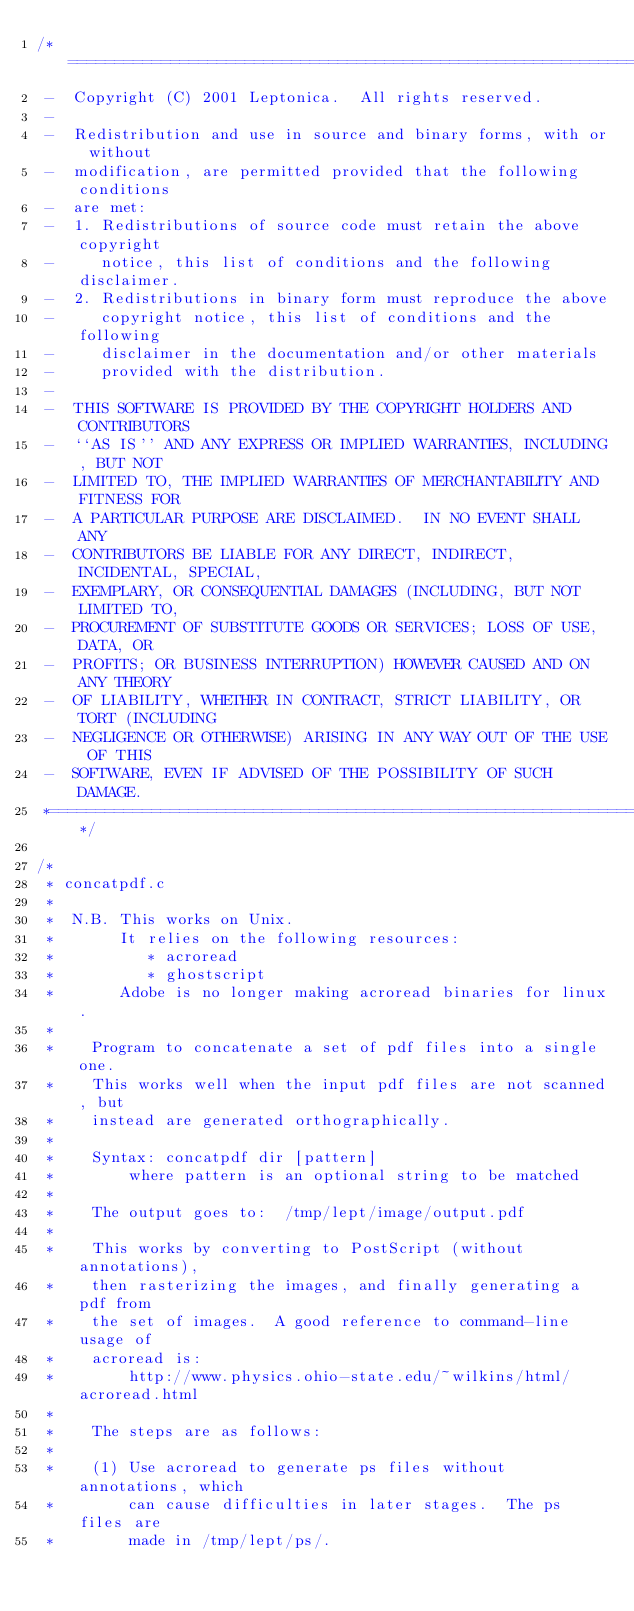Convert code to text. <code><loc_0><loc_0><loc_500><loc_500><_C_>/*====================================================================*
 -  Copyright (C) 2001 Leptonica.  All rights reserved.
 -
 -  Redistribution and use in source and binary forms, with or without
 -  modification, are permitted provided that the following conditions
 -  are met:
 -  1. Redistributions of source code must retain the above copyright
 -     notice, this list of conditions and the following disclaimer.
 -  2. Redistributions in binary form must reproduce the above
 -     copyright notice, this list of conditions and the following
 -     disclaimer in the documentation and/or other materials
 -     provided with the distribution.
 -
 -  THIS SOFTWARE IS PROVIDED BY THE COPYRIGHT HOLDERS AND CONTRIBUTORS
 -  ``AS IS'' AND ANY EXPRESS OR IMPLIED WARRANTIES, INCLUDING, BUT NOT
 -  LIMITED TO, THE IMPLIED WARRANTIES OF MERCHANTABILITY AND FITNESS FOR
 -  A PARTICULAR PURPOSE ARE DISCLAIMED.  IN NO EVENT SHALL ANY
 -  CONTRIBUTORS BE LIABLE FOR ANY DIRECT, INDIRECT, INCIDENTAL, SPECIAL,
 -  EXEMPLARY, OR CONSEQUENTIAL DAMAGES (INCLUDING, BUT NOT LIMITED TO,
 -  PROCUREMENT OF SUBSTITUTE GOODS OR SERVICES; LOSS OF USE, DATA, OR
 -  PROFITS; OR BUSINESS INTERRUPTION) HOWEVER CAUSED AND ON ANY THEORY
 -  OF LIABILITY, WHETHER IN CONTRACT, STRICT LIABILITY, OR TORT (INCLUDING
 -  NEGLIGENCE OR OTHERWISE) ARISING IN ANY WAY OUT OF THE USE OF THIS
 -  SOFTWARE, EVEN IF ADVISED OF THE POSSIBILITY OF SUCH DAMAGE.
 *====================================================================*/

/*
 * concatpdf.c
 *
 *  N.B. This works on Unix.
 *       It relies on the following resources:
 *          * acroread
 *          * ghostscript
 *       Adobe is no longer making acroread binaries for linux.
 *
 *    Program to concatenate a set of pdf files into a single one.
 *    This works well when the input pdf files are not scanned, but
 *    instead are generated orthographically.
 *
 *    Syntax: concatpdf dir [pattern]
 *        where pattern is an optional string to be matched
 *
 *    The output goes to:  /tmp/lept/image/output.pdf
 *
 *    This works by converting to PostScript (without annotations),
 *    then rasterizing the images, and finally generating a pdf from
 *    the set of images.  A good reference to command-line usage of
 *    acroread is:
 *        http://www.physics.ohio-state.edu/~wilkins/html/acroread.html
 *
 *    The steps are as follows:
 *
 *    (1) Use acroread to generate ps files without annotations, which
 *        can cause difficulties in later stages.  The ps files are
 *        made in /tmp/lept/ps/.</code> 